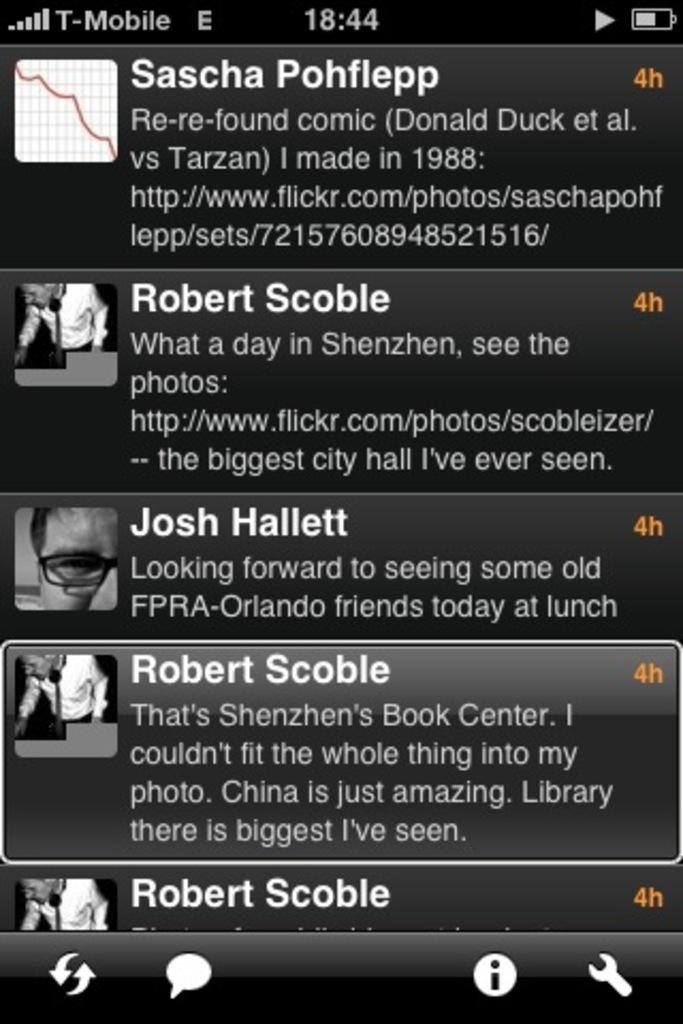What is the main object in the image? There is a screen in the image. What can be seen on the screen? There are people visible on the screen, along with symbols and text. How does the star affect the letters on the screen? There is no star present in the image, so it cannot affect the letters on the screen. 